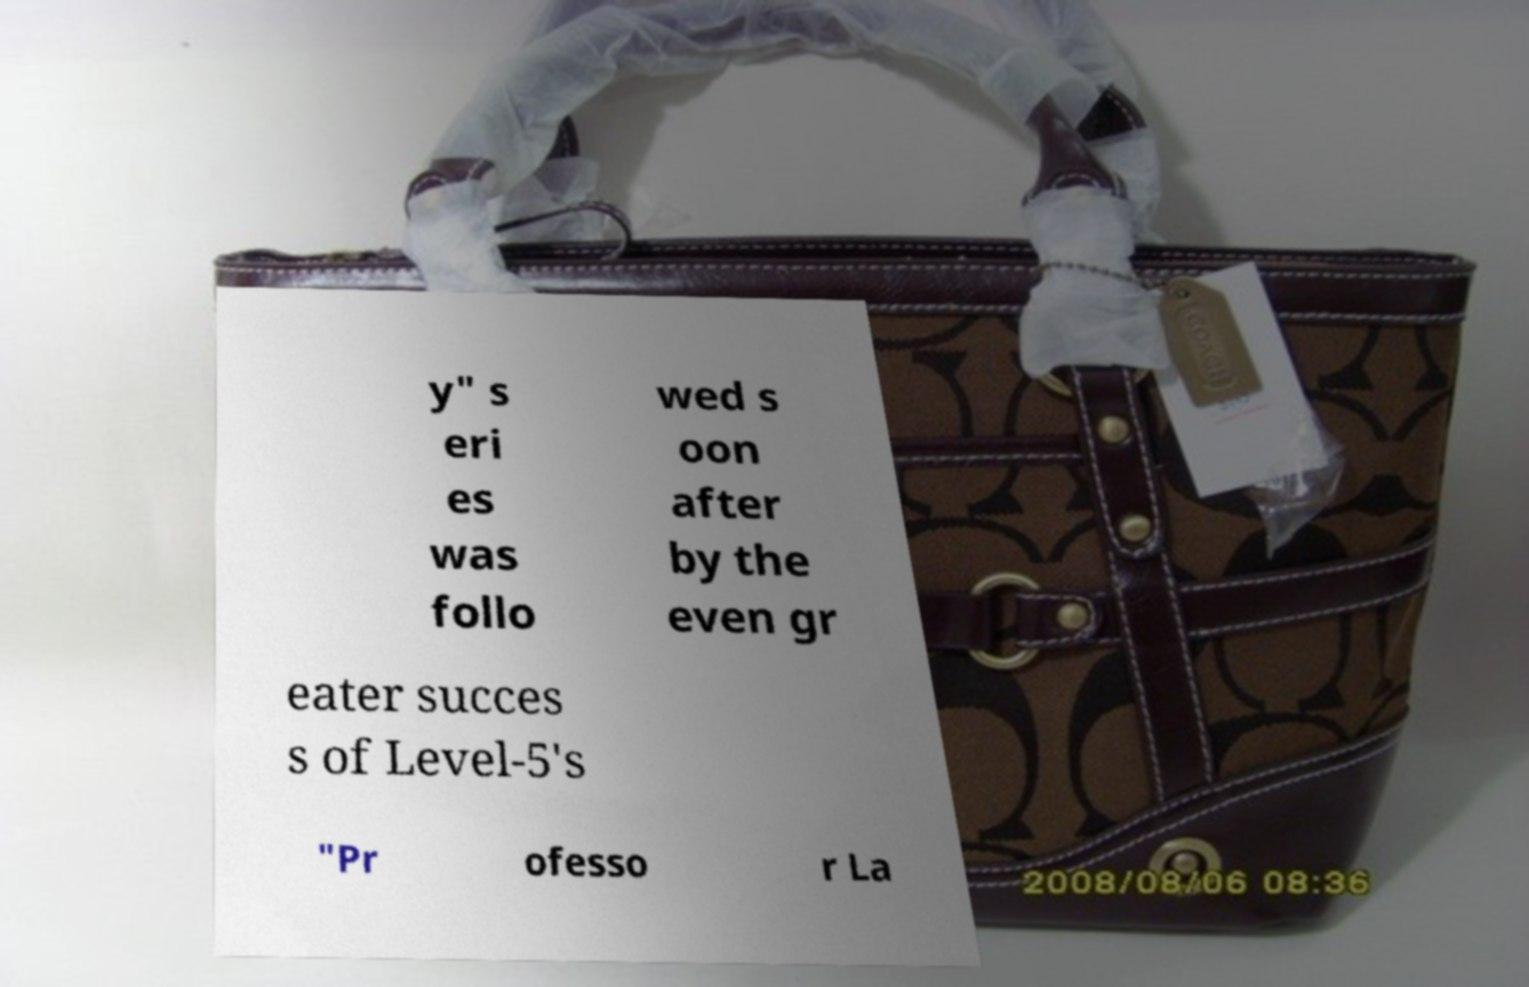Please identify and transcribe the text found in this image. y" s eri es was follo wed s oon after by the even gr eater succes s of Level-5's "Pr ofesso r La 